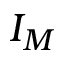Convert formula to latex. <formula><loc_0><loc_0><loc_500><loc_500>I _ { M }</formula> 